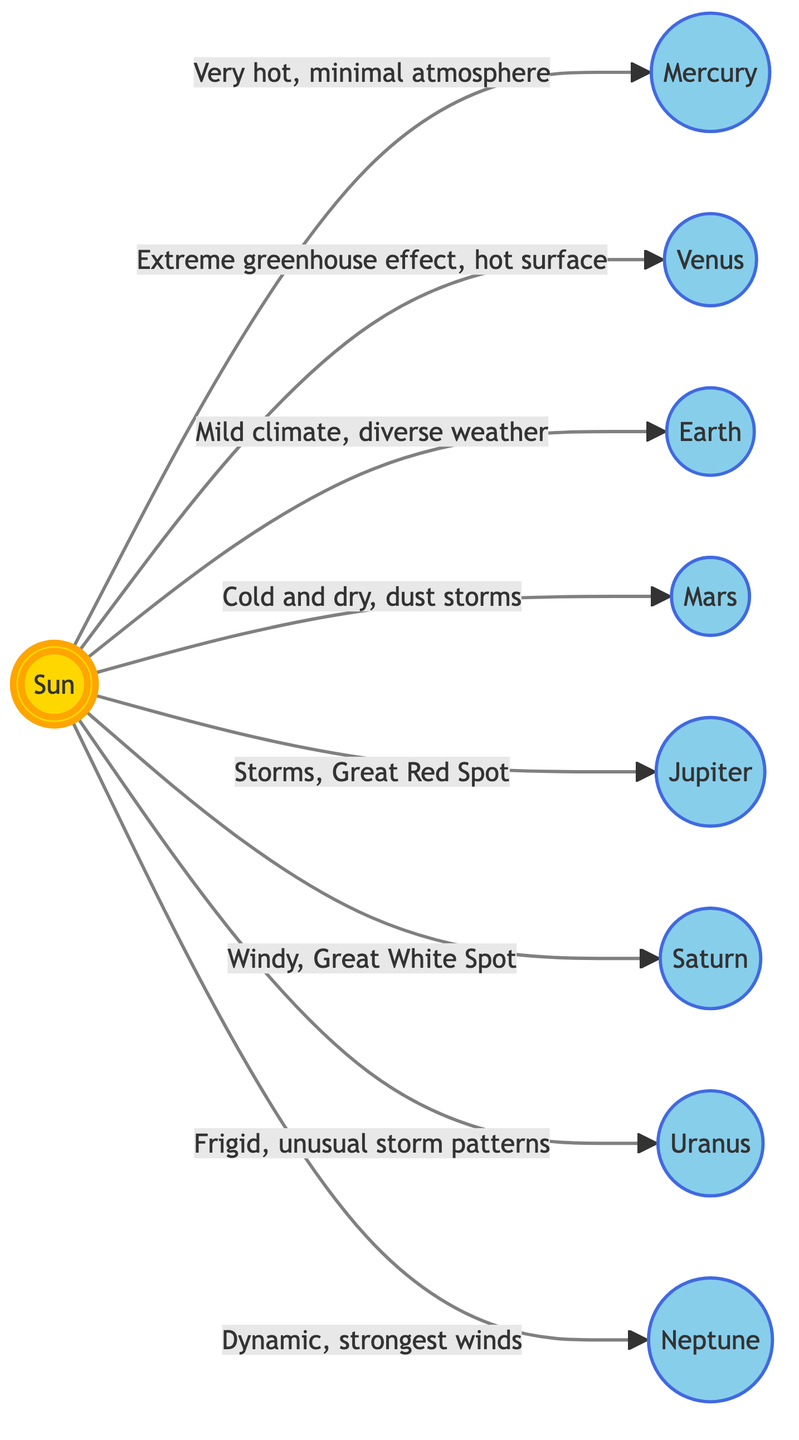What are the weather patterns associated with Venus? The diagram states that Venus has an "Extreme greenhouse effect" which leads to a "hot surface." This description provides clear information about the weather patterns specific to Venus.
Answer: Extreme greenhouse effect, hot surface Which planet has a mild climate according to the diagram? The diagram labels Earth with "Mild climate, diverse weather." From this, we can clearly identify Earth as the planet possessing this specific weather pattern.
Answer: Earth How many planets are shown in the diagram? Counting the planetary nodes: Mercury, Venus, Earth, Mars, Jupiter, Saturn, Uranus, and Neptune, the total comes to 8 planets depicted in the diagram.
Answer: 8 What weather phenomenon is described for Jupiter? The diagram indicates that Jupiter has "Storms, Great Red Spot." A direct reading of this information reveals Jupiter's unique weather characteristics.
Answer: Storms, Great Red Spot Which planet is described with "Dynamic, strongest winds"? According to the diagram, Neptune is noted for having "Dynamic, strongest winds." This description helps identify the specific weather traits of Neptune.
Answer: Neptune What is the relationship between the Sun and Saturn in the context of weather patterns? The diagram connects the Sun to Saturn with the label "Windy, Great White Spot." This shows that Saturn's weather is directly influenced by its position relative to the Sun, specifically indicating how the sun’s energy impacts its weather.
Answer: Windy, Great White Spot Which planet is noted for having dust storms? The diagram states that Mars experiences "Cold and dry, dust storms." By specifically looking at the description under Mars, we can answer this question regarding its weather.
Answer: Mars Is there any mention of storms in the description of Uranus? The diagram describes Uranus as having "Frigid, unusual storm patterns." Therefore, it is clear that Uranus has storms indicated in its weather description.
Answer: Yes 